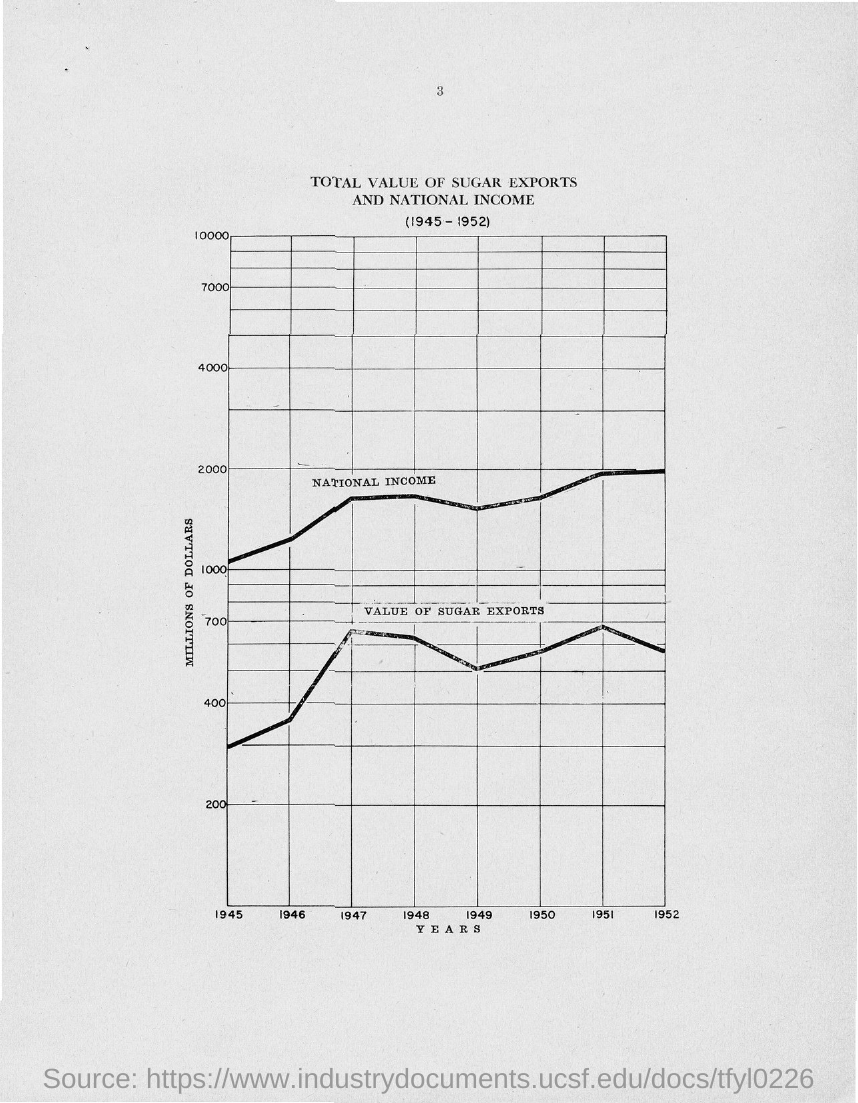Highlight a few significant elements in this photo. The x-axis in the plot displays the years. The y-axis represents the total amount of money spent on marketing campaigns, which is listed in millions of dollars. 